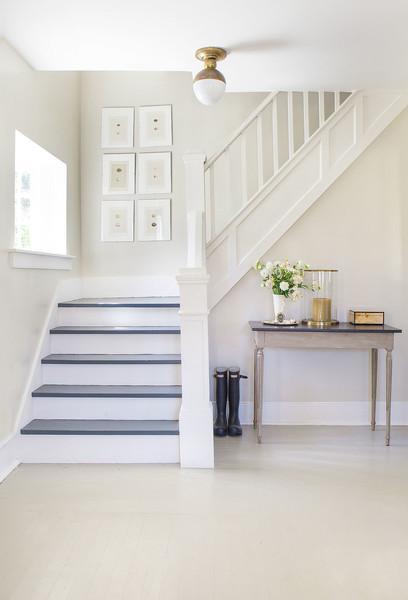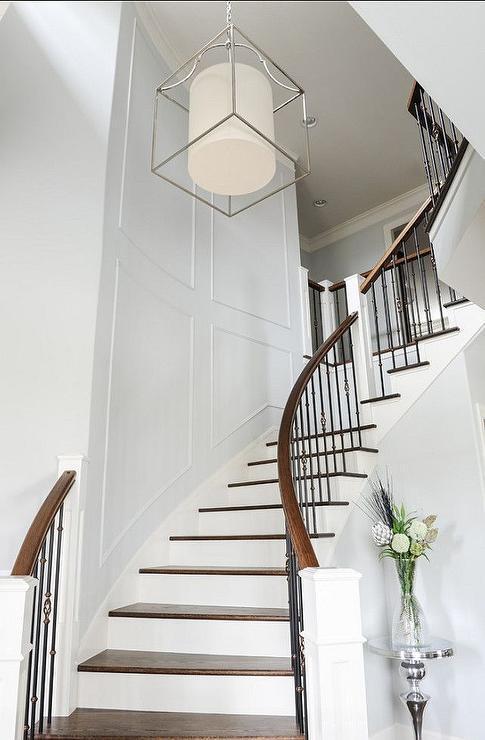The first image is the image on the left, the second image is the image on the right. Considering the images on both sides, is "Stockings are hanging from the left staircase." valid? Answer yes or no. No. The first image is the image on the left, the second image is the image on the right. Given the left and right images, does the statement "There is a railing decorated with holiday lights." hold true? Answer yes or no. No. 